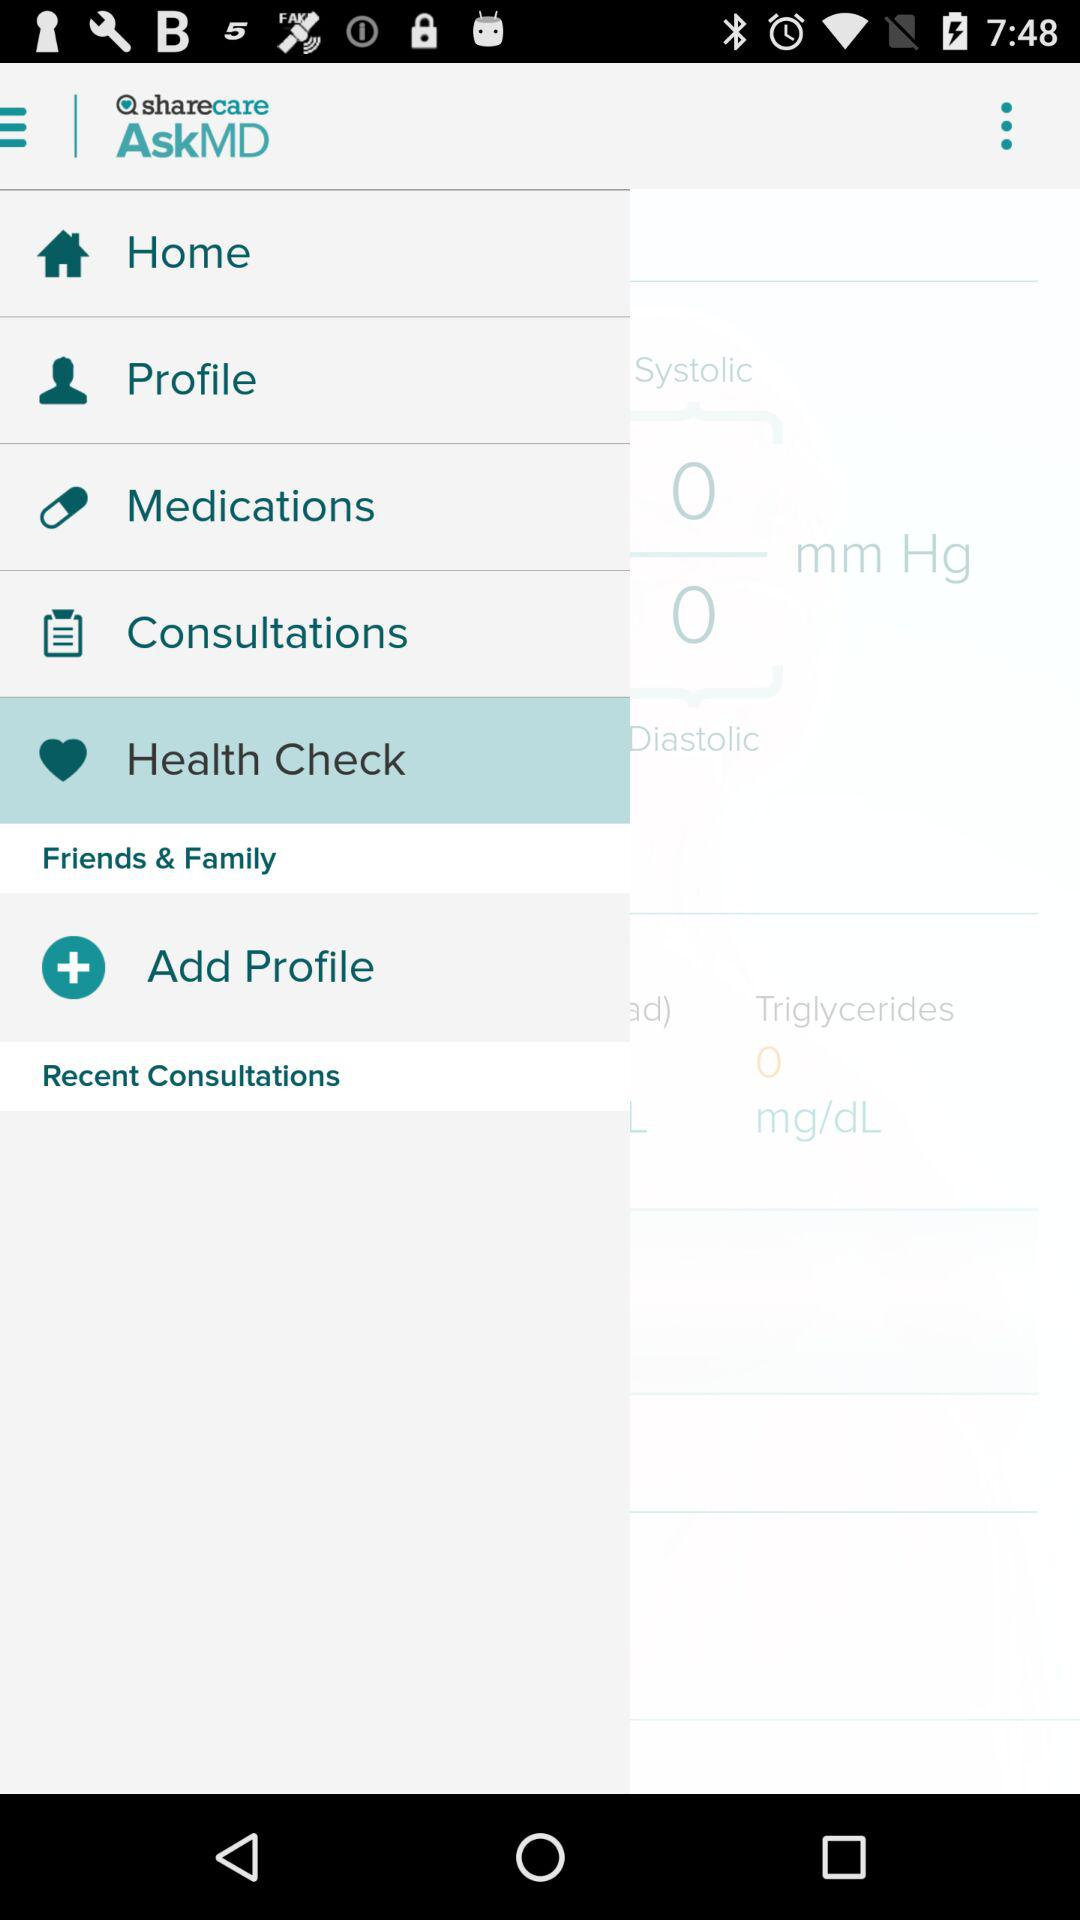What is the application name? The application name is "AskMD". 